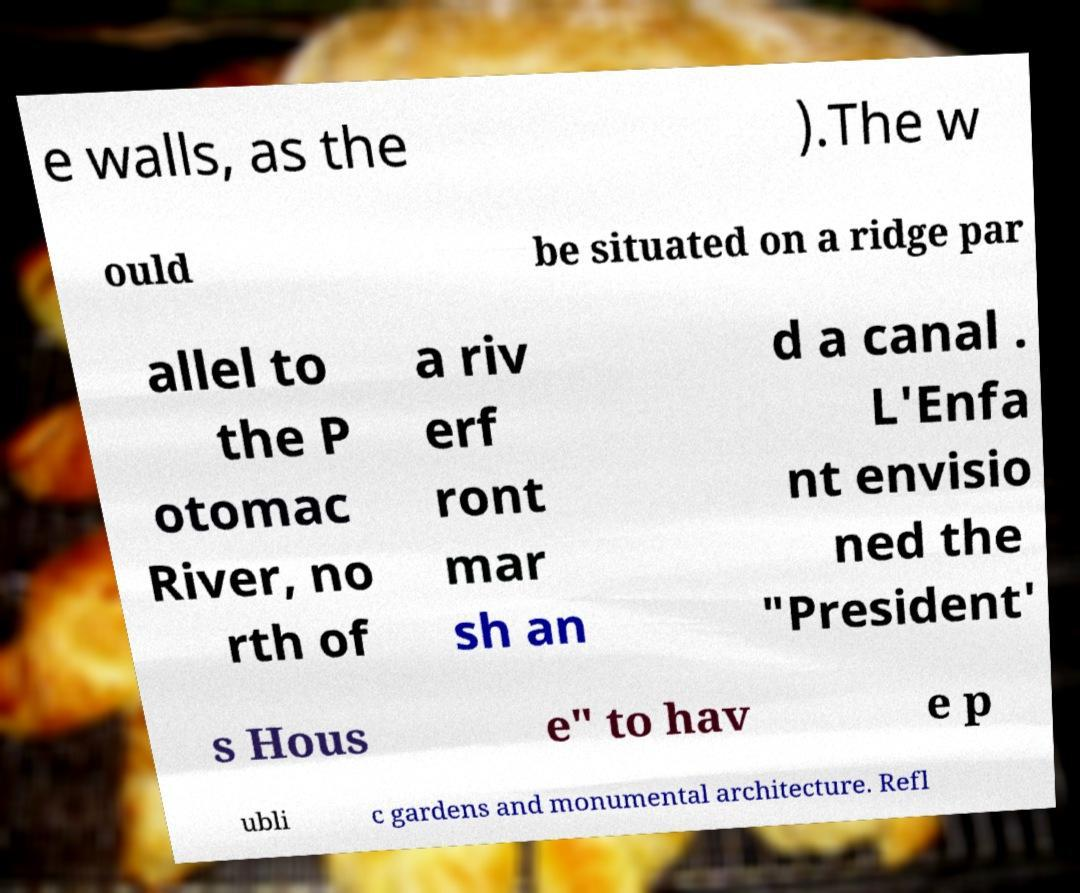Can you accurately transcribe the text from the provided image for me? e walls, as the ).The w ould be situated on a ridge par allel to the P otomac River, no rth of a riv erf ront mar sh an d a canal . L'Enfa nt envisio ned the "President' s Hous e" to hav e p ubli c gardens and monumental architecture. Refl 